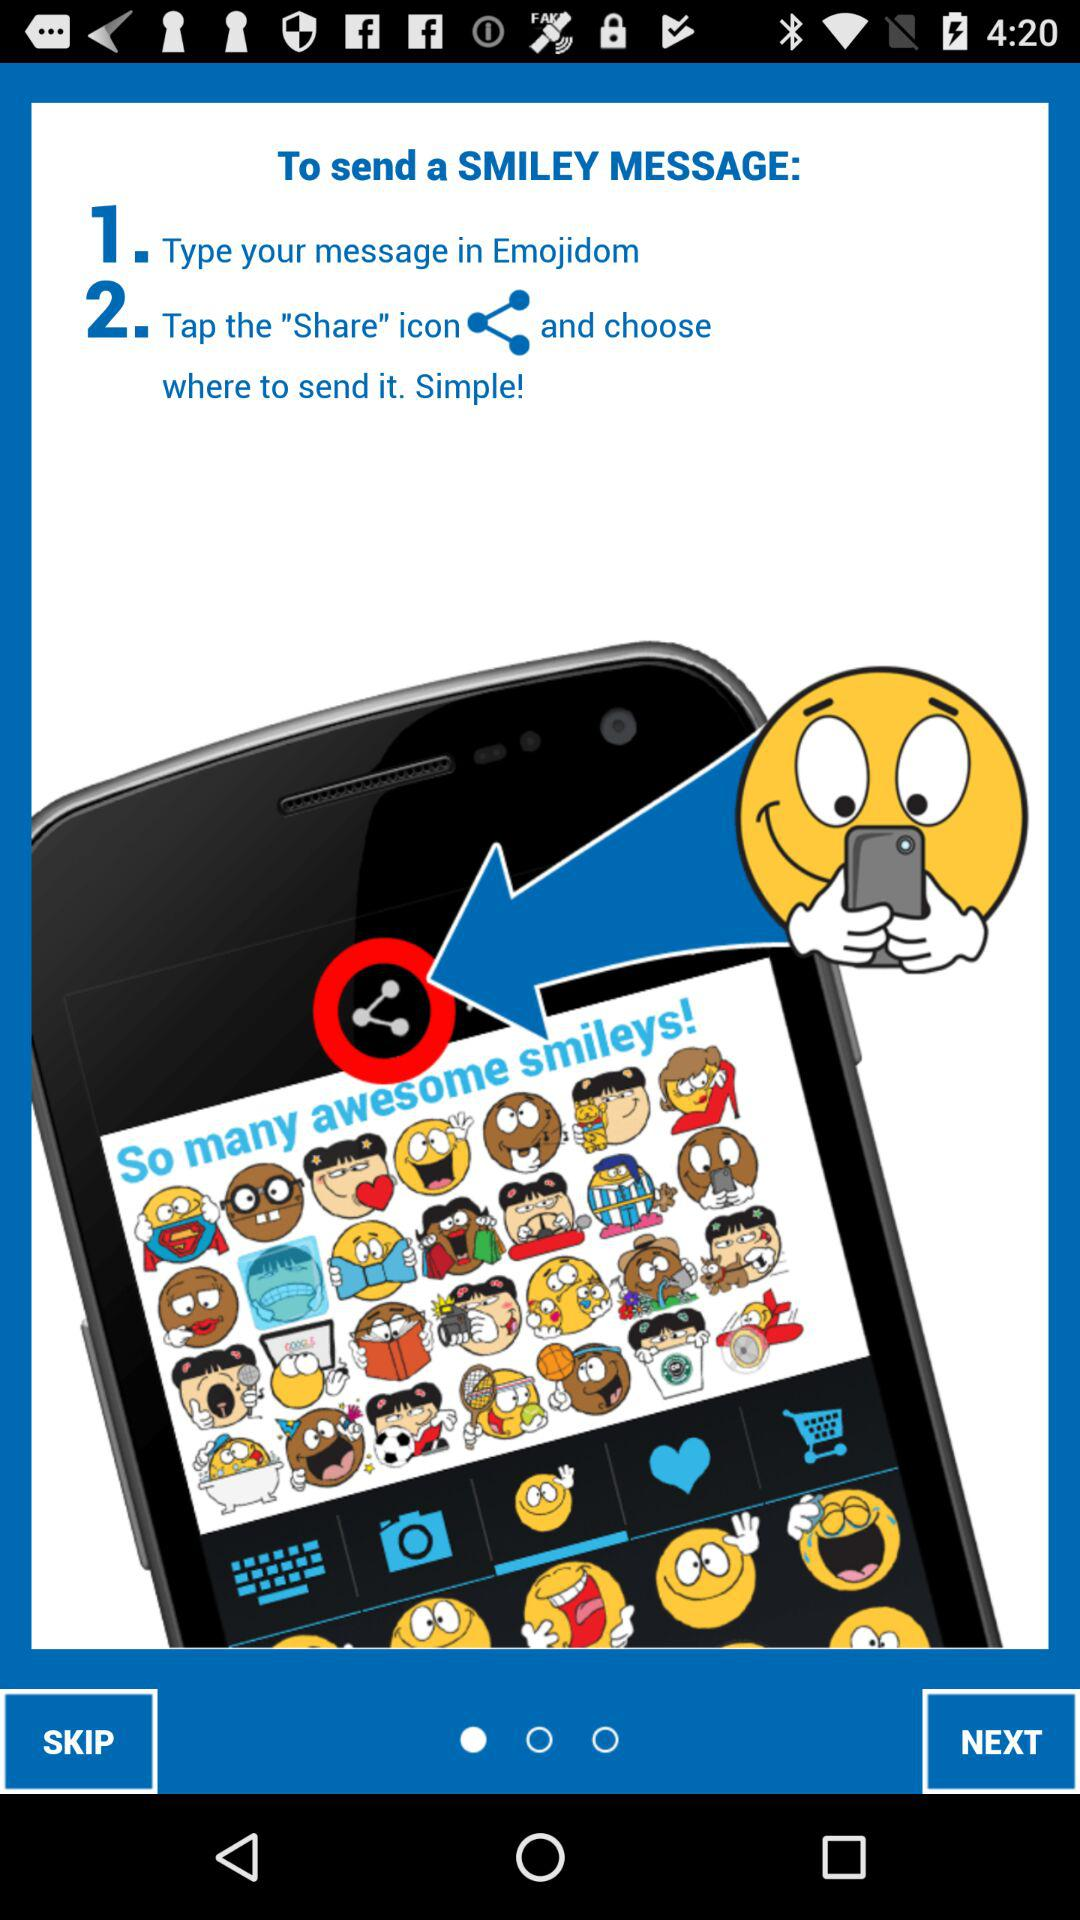How many steps are there to send a smiley message?
Answer the question using a single word or phrase. 2 